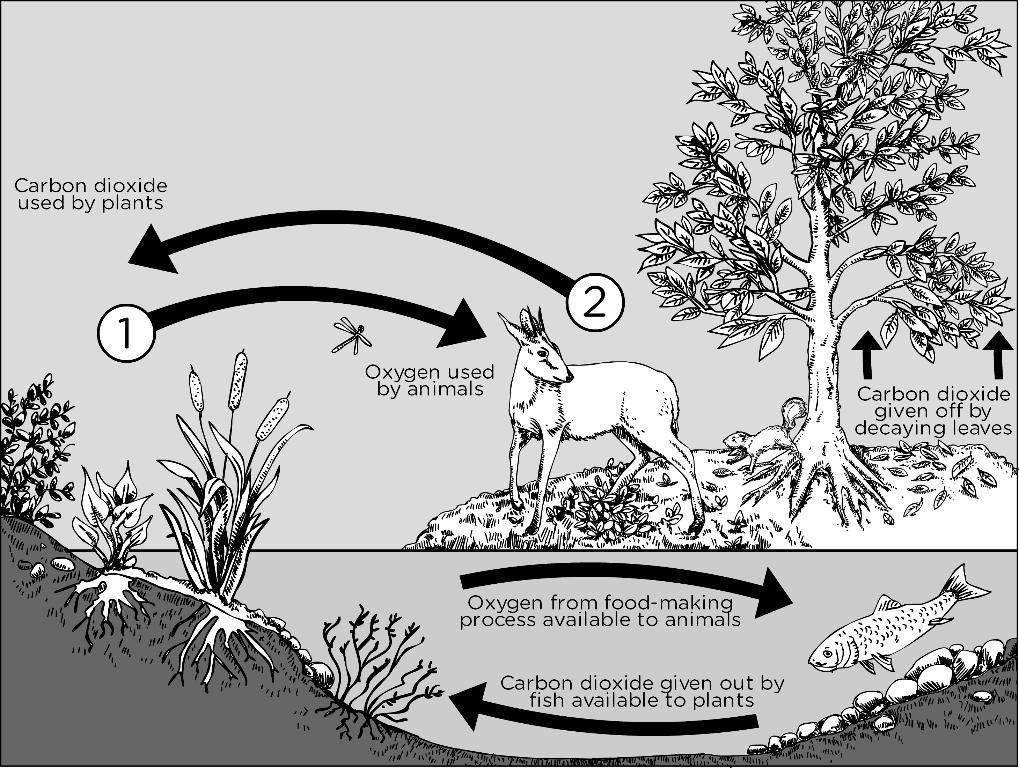Could you give a brief overview of what you see in this image? It is an animated image it is the life cycle of different species and the description of the process of usage of carbon dioxide and oxygen is mentioned in the picture,the relationship is between the plants and animals. 